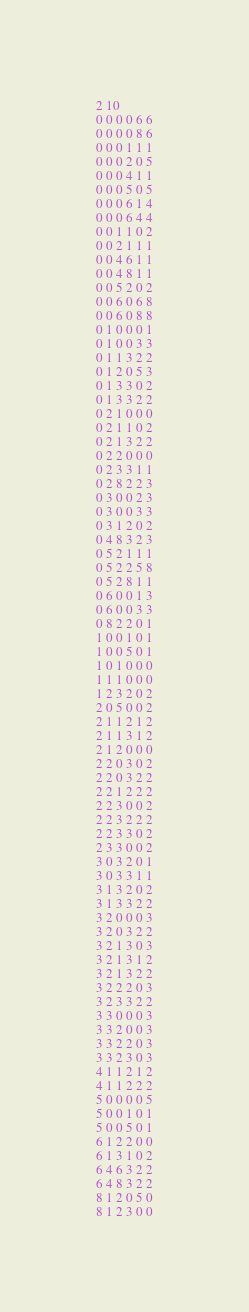<code> <loc_0><loc_0><loc_500><loc_500><_SQL_>2 10
0 0 0 0 6 6
0 0 0 0 8 6
0 0 0 1 1 1
0 0 0 2 0 5
0 0 0 4 1 1
0 0 0 5 0 5
0 0 0 6 1 4
0 0 0 6 4 4
0 0 1 1 0 2
0 0 2 1 1 1
0 0 4 6 1 1
0 0 4 8 1 1
0 0 5 2 0 2
0 0 6 0 6 8
0 0 6 0 8 8
0 1 0 0 0 1
0 1 0 0 3 3
0 1 1 3 2 2
0 1 2 0 5 3
0 1 3 3 0 2
0 1 3 3 2 2
0 2 1 0 0 0
0 2 1 1 0 2
0 2 1 3 2 2
0 2 2 0 0 0
0 2 3 3 1 1
0 2 8 2 2 3
0 3 0 0 2 3
0 3 0 0 3 3
0 3 1 2 0 2
0 4 8 3 2 3
0 5 2 1 1 1
0 5 2 2 5 8
0 5 2 8 1 1
0 6 0 0 1 3
0 6 0 0 3 3
0 8 2 2 0 1
1 0 0 1 0 1
1 0 0 5 0 1
1 0 1 0 0 0
1 1 1 0 0 0
1 2 3 2 0 2
2 0 5 0 0 2
2 1 1 2 1 2
2 1 1 3 1 2
2 1 2 0 0 0
2 2 0 3 0 2
2 2 0 3 2 2
2 2 1 2 2 2
2 2 3 0 0 2
2 2 3 2 2 2
2 2 3 3 0 2
2 3 3 0 0 2
3 0 3 2 0 1
3 0 3 3 1 1
3 1 3 2 0 2
3 1 3 3 2 2
3 2 0 0 0 3
3 2 0 3 2 2
3 2 1 3 0 3
3 2 1 3 1 2
3 2 1 3 2 2
3 2 2 2 0 3
3 2 3 3 2 2
3 3 0 0 0 3
3 3 2 0 0 3
3 3 2 2 0 3
3 3 2 3 0 3
4 1 1 2 1 2
4 1 1 2 2 2
5 0 0 0 0 5
5 0 0 1 0 1
5 0 0 5 0 1
6 1 2 2 0 0
6 1 3 1 0 2
6 4 6 3 2 2
6 4 8 3 2 2
8 1 2 0 5 0
8 1 2 3 0 0
</code> 